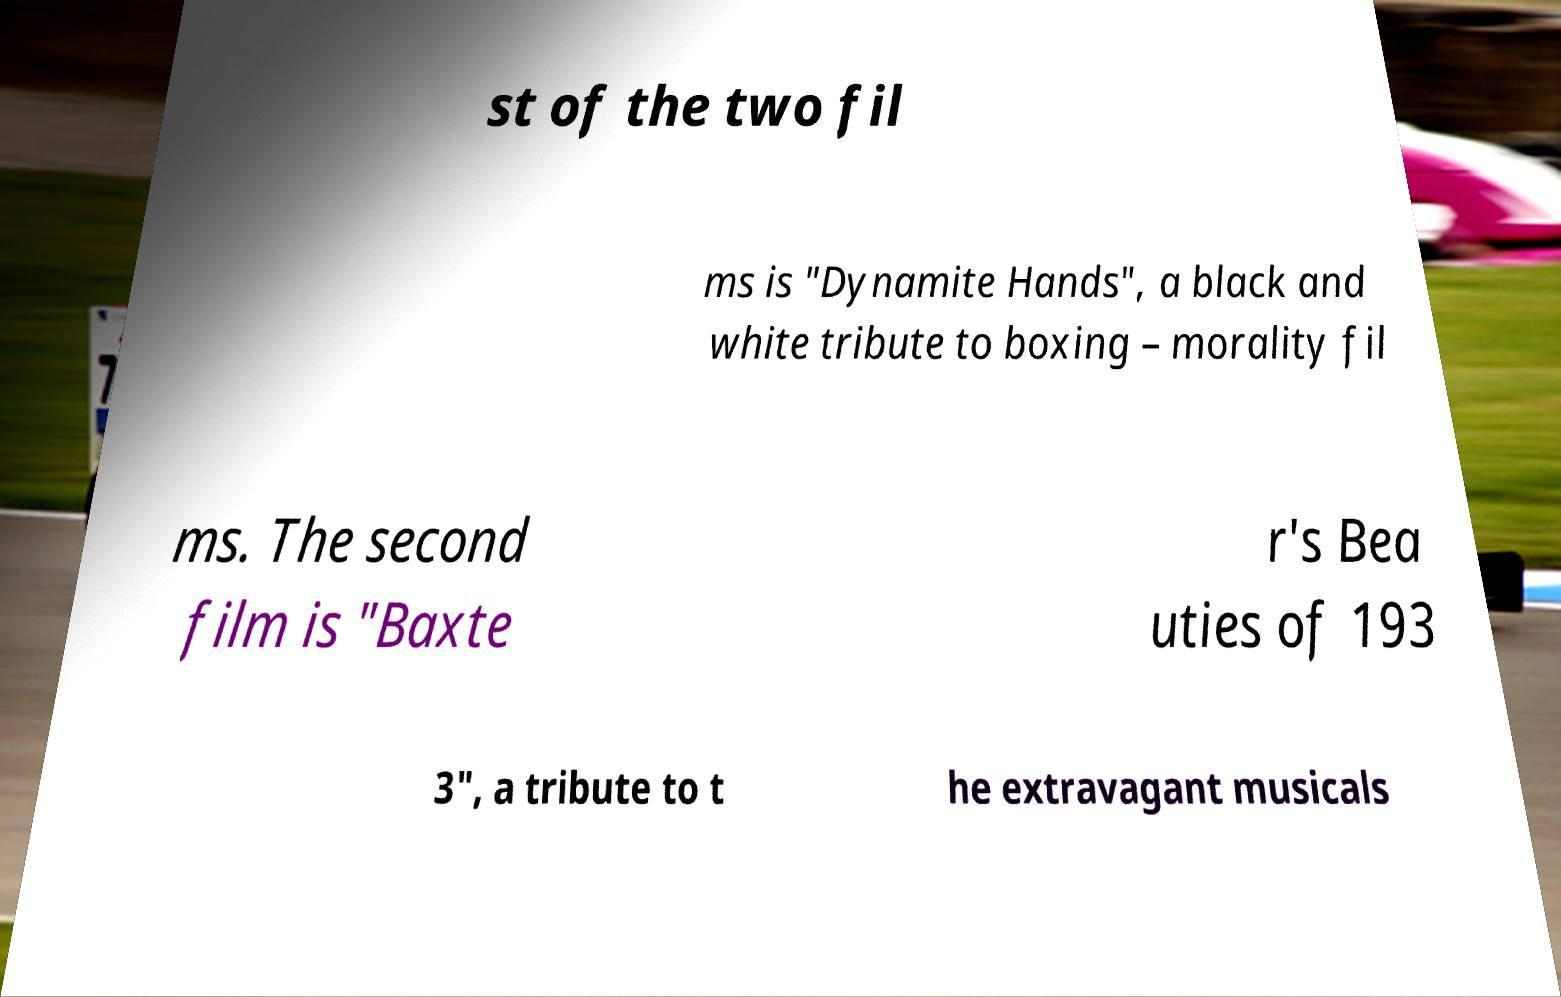Please identify and transcribe the text found in this image. st of the two fil ms is "Dynamite Hands", a black and white tribute to boxing – morality fil ms. The second film is "Baxte r's Bea uties of 193 3", a tribute to t he extravagant musicals 